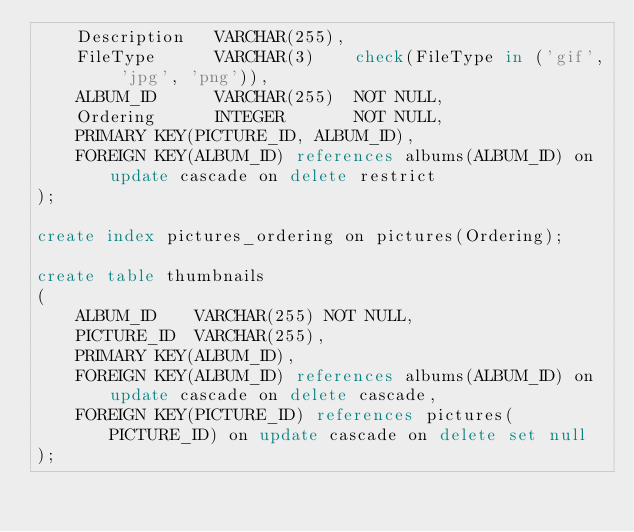<code> <loc_0><loc_0><loc_500><loc_500><_SQL_>	Description   VARCHAR(255),
	FileType      VARCHAR(3)    check(FileType in ('gif', 'jpg', 'png')),
	ALBUM_ID      VARCHAR(255)  NOT NULL,
	Ordering      INTEGER       NOT NULL,
	PRIMARY KEY(PICTURE_ID, ALBUM_ID),
	FOREIGN KEY(ALBUM_ID) references albums(ALBUM_ID) on update cascade on delete restrict
);

create index pictures_ordering on pictures(Ordering);

create table thumbnails
(
	ALBUM_ID    VARCHAR(255) NOT NULL,
	PICTURE_ID  VARCHAR(255),
	PRIMARY KEY(ALBUM_ID),
	FOREIGN KEY(ALBUM_ID) references albums(ALBUM_ID) on update cascade on delete cascade,
	FOREIGN KEY(PICTURE_ID) references pictures(PICTURE_ID) on update cascade on delete set null
);
</code> 